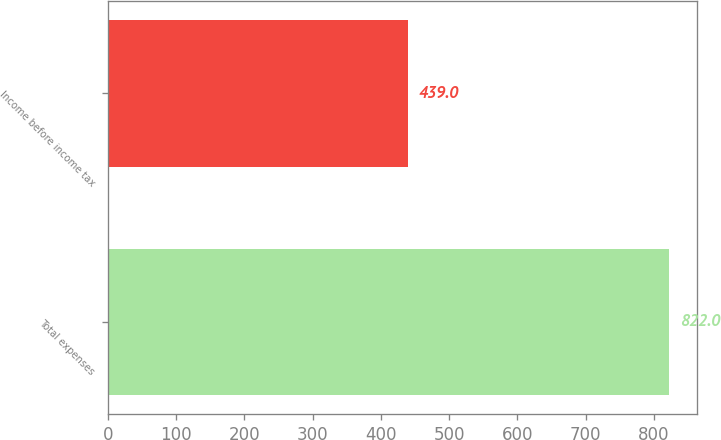Convert chart to OTSL. <chart><loc_0><loc_0><loc_500><loc_500><bar_chart><fcel>Total expenses<fcel>Income before income tax<nl><fcel>822<fcel>439<nl></chart> 